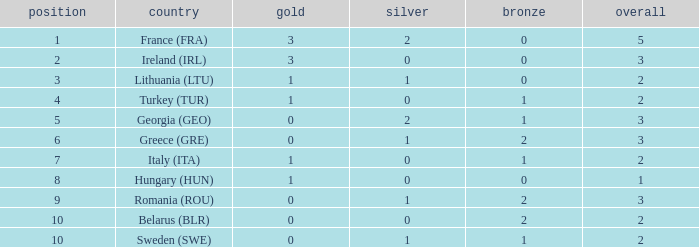What's the rank of Turkey (TUR) with a total more than 2? 0.0. Could you help me parse every detail presented in this table? {'header': ['position', 'country', 'gold', 'silver', 'bronze', 'overall'], 'rows': [['1', 'France (FRA)', '3', '2', '0', '5'], ['2', 'Ireland (IRL)', '3', '0', '0', '3'], ['3', 'Lithuania (LTU)', '1', '1', '0', '2'], ['4', 'Turkey (TUR)', '1', '0', '1', '2'], ['5', 'Georgia (GEO)', '0', '2', '1', '3'], ['6', 'Greece (GRE)', '0', '1', '2', '3'], ['7', 'Italy (ITA)', '1', '0', '1', '2'], ['8', 'Hungary (HUN)', '1', '0', '0', '1'], ['9', 'Romania (ROU)', '0', '1', '2', '3'], ['10', 'Belarus (BLR)', '0', '0', '2', '2'], ['10', 'Sweden (SWE)', '0', '1', '1', '2']]} 